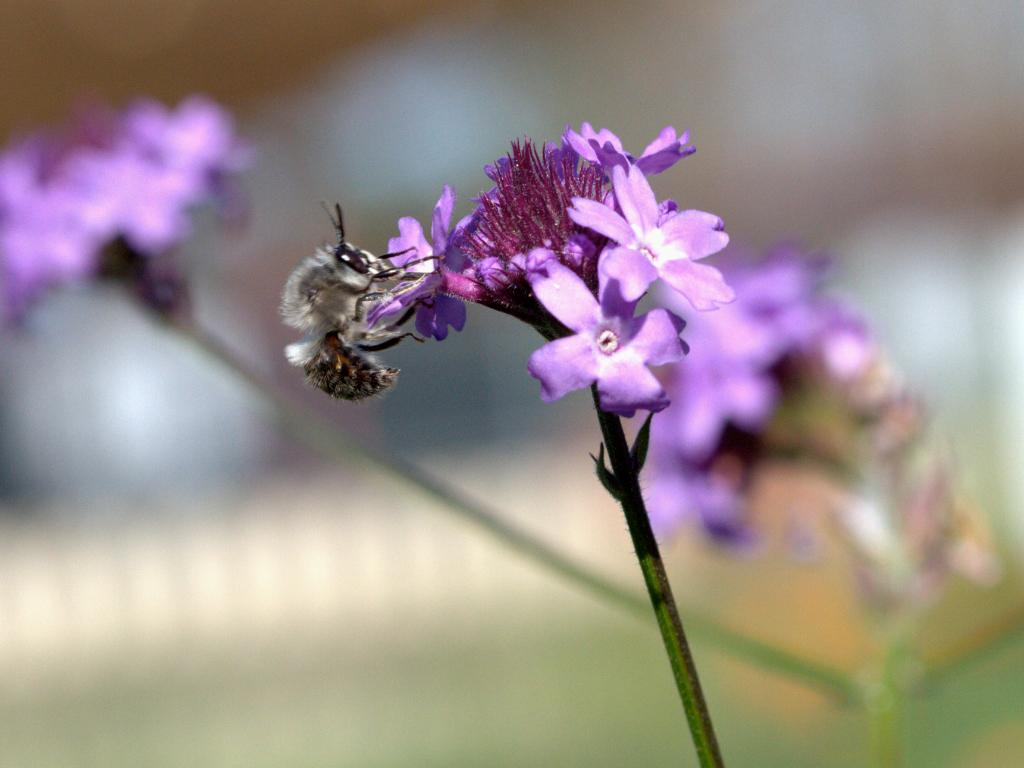What type of living organisms can be seen in the image? There are flowers and an insect in the image. What part of the flowers is visible in the image? The stems of the flowers are visible in the image. Can you describe the insect in the image? There is an insect on a flower in the image. What is the background of the image like? The background of the image has a blurred view. What type of cheese is being used as a desk in the image? There is no cheese or desk present in the image. 